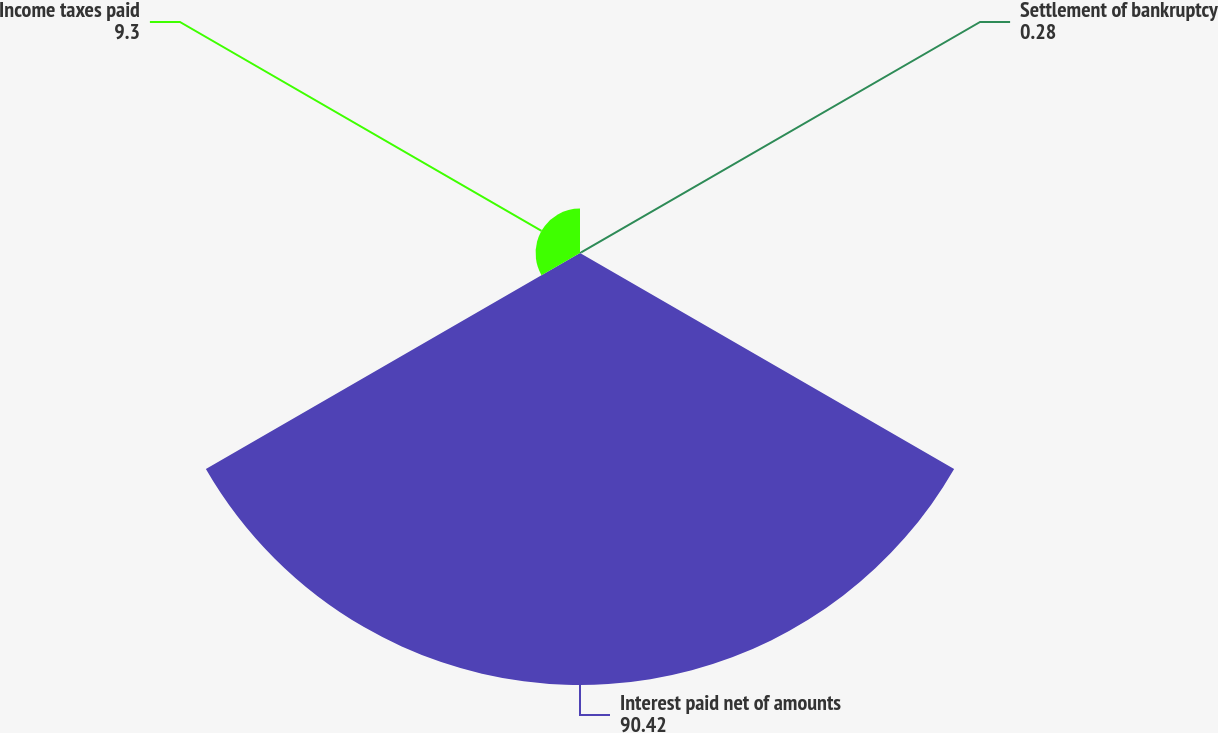<chart> <loc_0><loc_0><loc_500><loc_500><pie_chart><fcel>Settlement of bankruptcy<fcel>Interest paid net of amounts<fcel>Income taxes paid<nl><fcel>0.28%<fcel>90.42%<fcel>9.3%<nl></chart> 